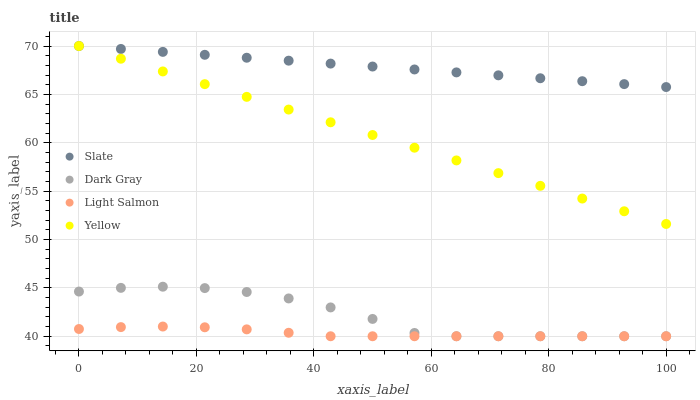Does Light Salmon have the minimum area under the curve?
Answer yes or no. Yes. Does Slate have the maximum area under the curve?
Answer yes or no. Yes. Does Slate have the minimum area under the curve?
Answer yes or no. No. Does Light Salmon have the maximum area under the curve?
Answer yes or no. No. Is Yellow the smoothest?
Answer yes or no. Yes. Is Dark Gray the roughest?
Answer yes or no. Yes. Is Slate the smoothest?
Answer yes or no. No. Is Slate the roughest?
Answer yes or no. No. Does Dark Gray have the lowest value?
Answer yes or no. Yes. Does Slate have the lowest value?
Answer yes or no. No. Does Yellow have the highest value?
Answer yes or no. Yes. Does Light Salmon have the highest value?
Answer yes or no. No. Is Light Salmon less than Slate?
Answer yes or no. Yes. Is Yellow greater than Light Salmon?
Answer yes or no. Yes. Does Dark Gray intersect Light Salmon?
Answer yes or no. Yes. Is Dark Gray less than Light Salmon?
Answer yes or no. No. Is Dark Gray greater than Light Salmon?
Answer yes or no. No. Does Light Salmon intersect Slate?
Answer yes or no. No. 